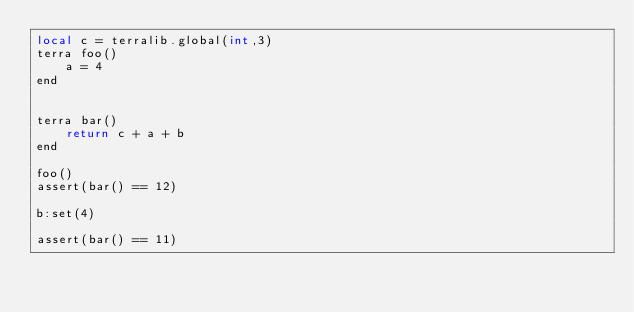<code> <loc_0><loc_0><loc_500><loc_500><_Perl_>local c = terralib.global(int,3)
terra foo()
	a = 4
end


terra bar()
	return c + a + b
end

foo()
assert(bar() == 12)

b:set(4)

assert(bar() == 11)</code> 